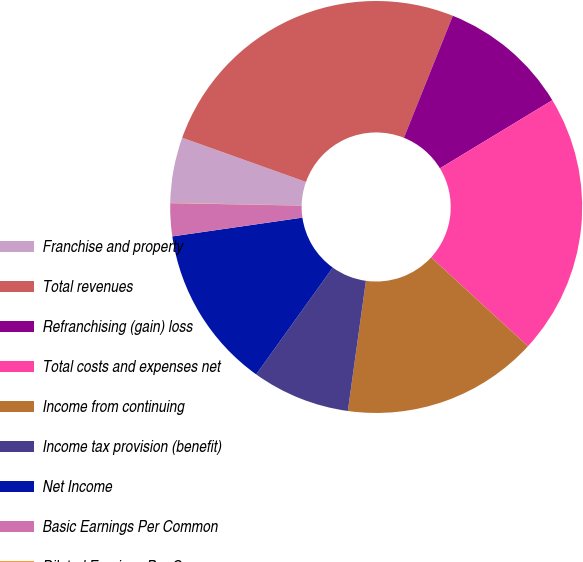Convert chart. <chart><loc_0><loc_0><loc_500><loc_500><pie_chart><fcel>Franchise and property<fcel>Total revenues<fcel>Refranchising (gain) loss<fcel>Total costs and expenses net<fcel>Income from continuing<fcel>Income tax provision (benefit)<fcel>Net Income<fcel>Basic Earnings Per Common<fcel>Diluted Earnings Per Common<nl><fcel>5.14%<fcel>25.61%<fcel>10.26%<fcel>20.49%<fcel>15.38%<fcel>7.7%<fcel>12.82%<fcel>2.58%<fcel>0.02%<nl></chart> 